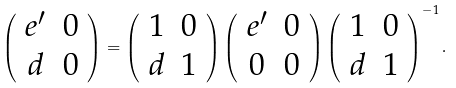<formula> <loc_0><loc_0><loc_500><loc_500>\left ( \begin{array} { c c } e ^ { \prime } & 0 \\ d & 0 \end{array} \right ) = \left ( \begin{array} { c c } 1 & 0 \\ d & 1 \end{array} \right ) \left ( \begin{array} { c c } e ^ { \prime } & 0 \\ 0 & 0 \end{array} \right ) \left ( \begin{array} { c c } 1 & 0 \\ d & 1 \end{array} \right ) ^ { - 1 } .</formula> 